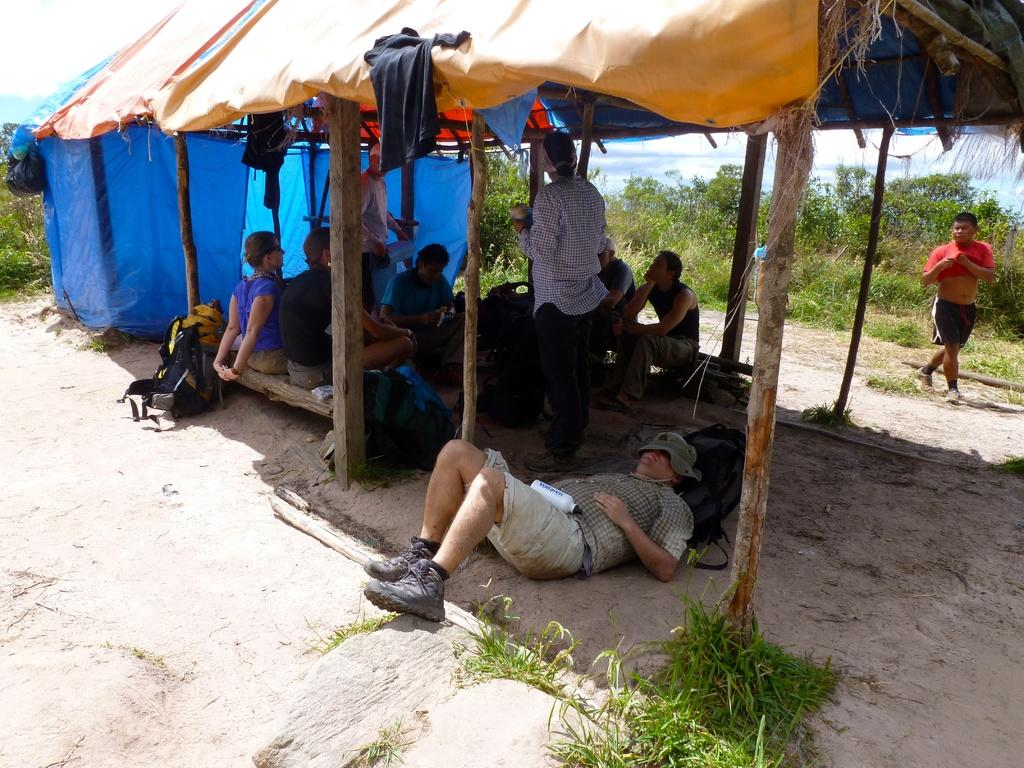Who or what can be seen in the image? There are people in the image. Where are the people located in the image? The people are under a hut. What can be seen in the background of the image? There are plants in the background of the image. How far away is the chicken from the people in the image? There is no chicken present in the image, so it cannot be determined how far away it might be from the people. 